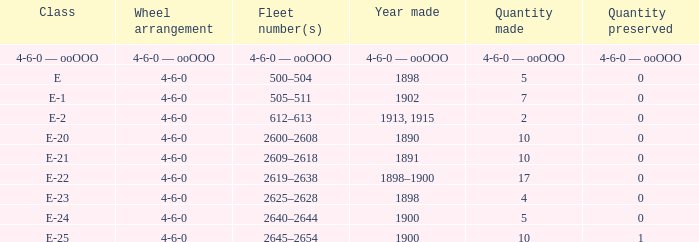What is the quantity preserved of the e-1 class? 0.0. 